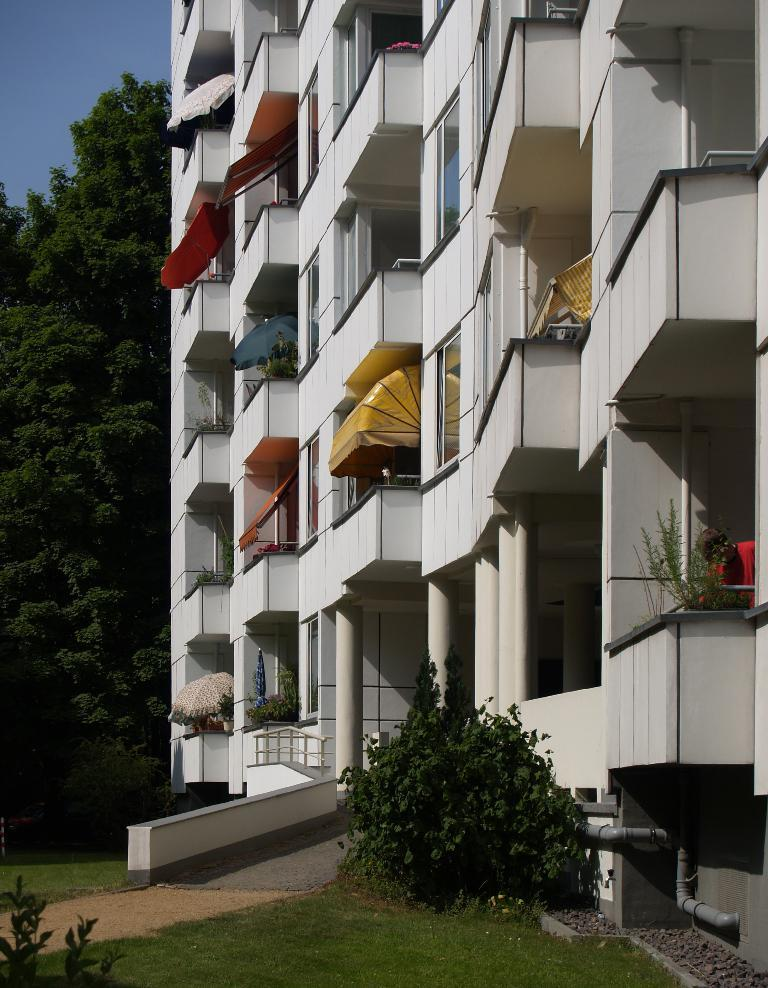What type of structure is present in the image? There is a building in the image. What architectural features can be seen in the image? There are pillars and railing in the image. What type of vegetation is present in the image? There are plants, grass, and a tree in the image. What part of the natural environment is visible in the image? The sky is visible in the image. What other objects can be seen in the image? There are objects in the image. How many cacti are visible in the image? There are no cacti present in the image. Can you tell me how many cats are sitting on the railing in the image? There are no cats present in the image. What type of neck accessory is the tree wearing in the image? There are no neck accessories present in the image, as trees do not wear such items. 